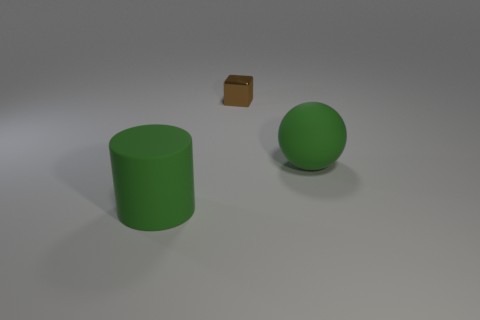What material is the large thing in front of the green rubber thing that is behind the green rubber cylinder to the left of the metal block? The large object in front of the green rubber item, which is behind the green cylinder and to the left of the small metal block, appears to have a texture and sheen that suggest it's made of a matte plastic material. 